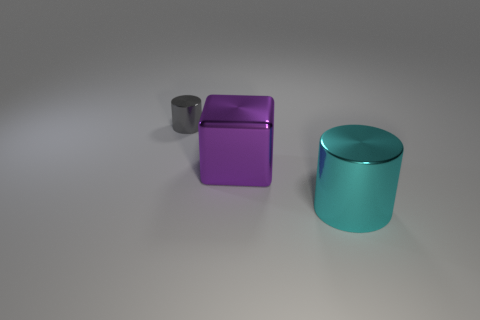Are there any other things that are the same size as the gray metallic thing?
Provide a succinct answer. No. What number of other large shiny blocks have the same color as the big cube?
Provide a short and direct response. 0. There is a small metallic thing; is its color the same as the cylinder to the right of the small shiny thing?
Offer a terse response. No. What number of things are either purple balls or metal things that are on the left side of the cyan cylinder?
Ensure brevity in your answer.  2. There is a cylinder that is behind the shiny cylinder that is right of the cube; what size is it?
Give a very brief answer. Small. Is the number of purple blocks that are on the left side of the tiny gray metal object the same as the number of cyan metal things that are behind the large shiny cube?
Give a very brief answer. Yes. Is there a large cyan shiny cylinder that is left of the metallic cylinder that is to the right of the gray shiny thing?
Ensure brevity in your answer.  No. What is the shape of the large object that is made of the same material as the large cylinder?
Provide a succinct answer. Cube. Are there any other things that have the same color as the metallic block?
Your answer should be compact. No. What material is the purple cube that is left of the cylinder that is in front of the block made of?
Your answer should be very brief. Metal. 